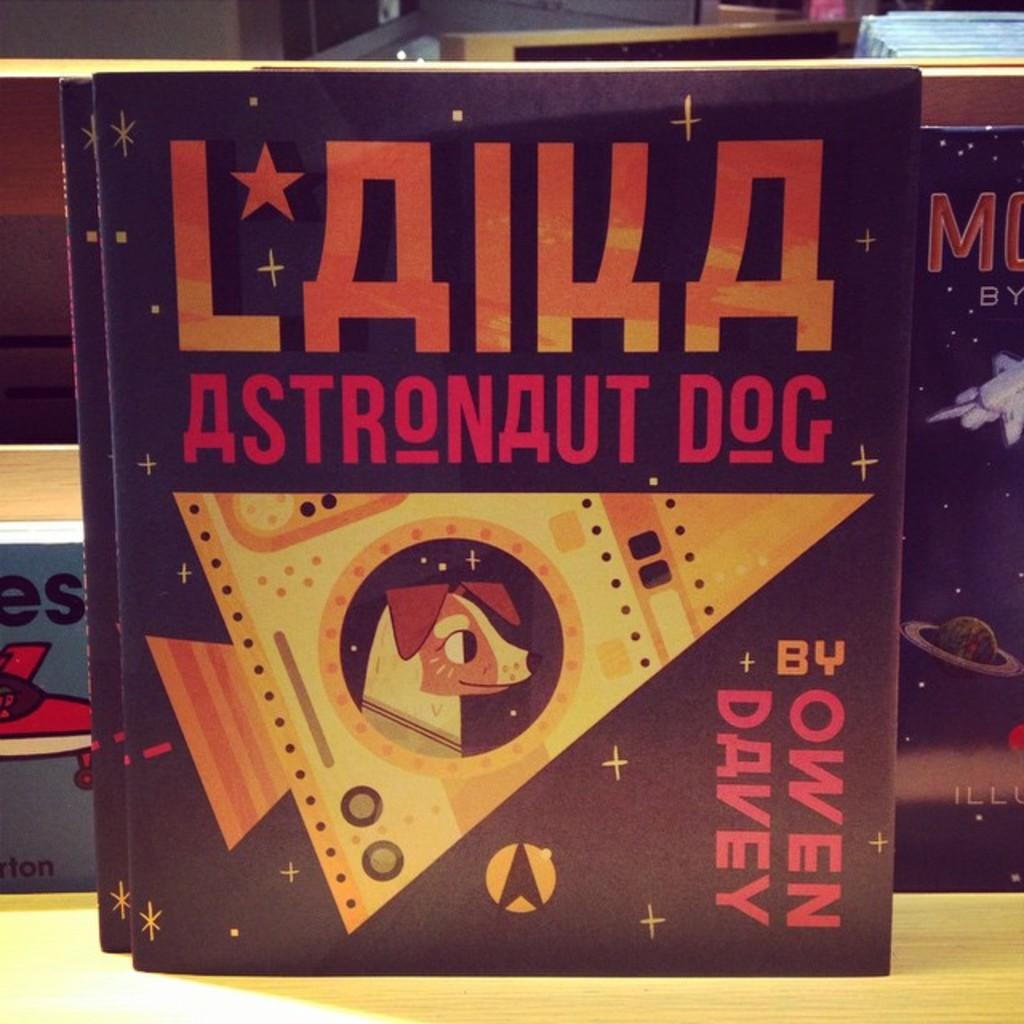Provide a one-sentence caption for the provided image. The title of the book is Laika Astronaut dog is displayed. 